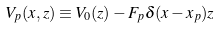Convert formula to latex. <formula><loc_0><loc_0><loc_500><loc_500>V _ { p } ( x , z ) \equiv V _ { 0 } ( z ) - F _ { p } \delta ( x - x _ { p } ) z</formula> 